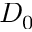Convert formula to latex. <formula><loc_0><loc_0><loc_500><loc_500>D _ { 0 }</formula> 